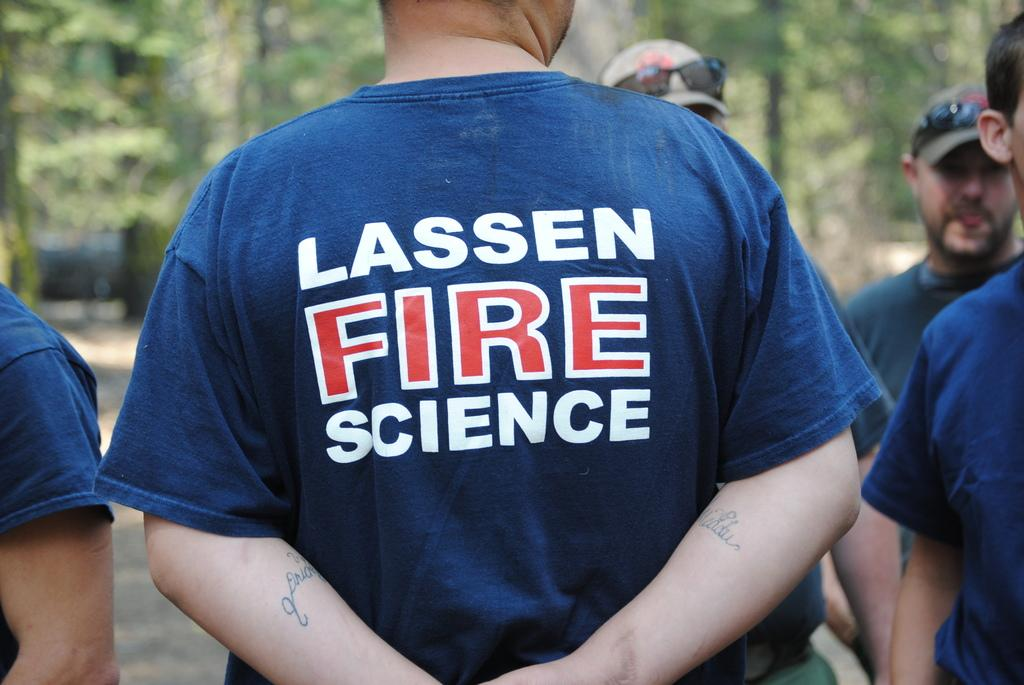Provide a one-sentence caption for the provided image. A man stands with his back to the camera wearing a blue top with Lassen Fire Science written on it. 